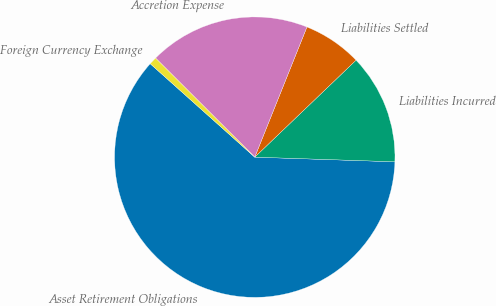Convert chart to OTSL. <chart><loc_0><loc_0><loc_500><loc_500><pie_chart><fcel>Asset Retirement Obligations<fcel>Liabilities Incurred<fcel>Liabilities Settled<fcel>Accretion Expense<fcel>Foreign Currency Exchange<nl><fcel>61.08%<fcel>12.68%<fcel>6.78%<fcel>18.58%<fcel>0.88%<nl></chart> 